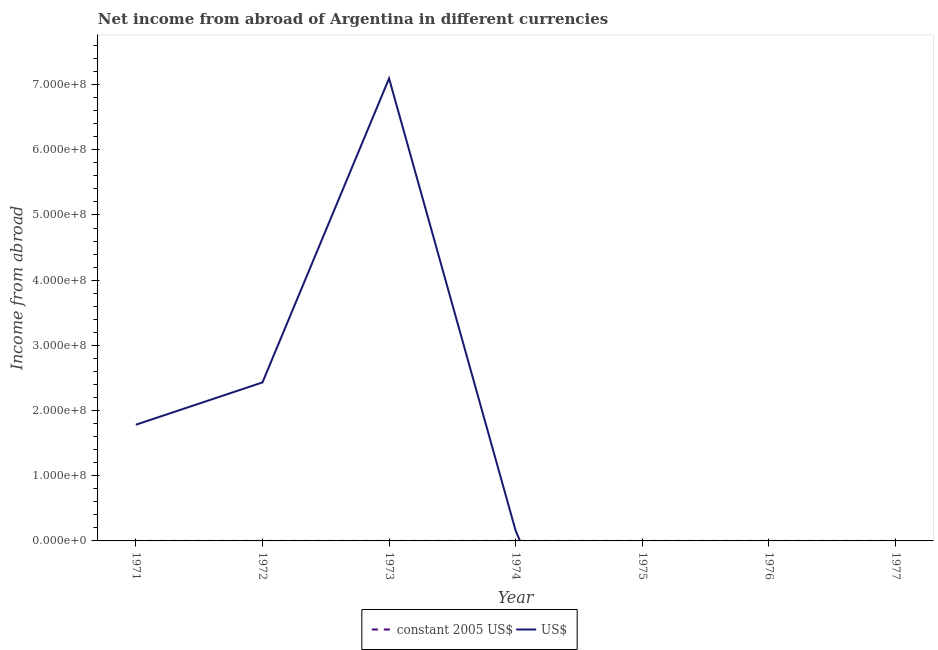Across all years, what is the maximum income from abroad in us$?
Offer a terse response. 7.09e+08. Across all years, what is the minimum income from abroad in constant 2005 us$?
Make the answer very short. 0. In which year was the income from abroad in constant 2005 us$ maximum?
Give a very brief answer. 1975. What is the total income from abroad in us$ in the graph?
Provide a succinct answer. 1.15e+09. What is the difference between the income from abroad in us$ in 1972 and that in 1973?
Offer a terse response. -4.66e+08. What is the difference between the income from abroad in constant 2005 us$ in 1977 and the income from abroad in us$ in 1973?
Your response must be concise. -7.09e+08. What is the average income from abroad in constant 2005 us$ per year?
Give a very brief answer. 0.05. In the year 1973, what is the difference between the income from abroad in constant 2005 us$ and income from abroad in us$?
Your answer should be very brief. -7.09e+08. In how many years, is the income from abroad in us$ greater than 340000000 units?
Give a very brief answer. 1. What is the ratio of the income from abroad in constant 2005 us$ in 1975 to that in 1976?
Give a very brief answer. 8.47. Is the income from abroad in constant 2005 us$ in 1971 less than that in 1976?
Make the answer very short. Yes. What is the difference between the highest and the second highest income from abroad in constant 2005 us$?
Keep it short and to the point. 0.23. What is the difference between the highest and the lowest income from abroad in constant 2005 us$?
Provide a succinct answer. 0.26. Is the sum of the income from abroad in constant 2005 us$ in 1974 and 1976 greater than the maximum income from abroad in us$ across all years?
Your answer should be very brief. No. Does the income from abroad in us$ monotonically increase over the years?
Your response must be concise. No. Is the income from abroad in us$ strictly less than the income from abroad in constant 2005 us$ over the years?
Make the answer very short. No. How many lines are there?
Keep it short and to the point. 2. How many years are there in the graph?
Provide a short and direct response. 7. What is the difference between two consecutive major ticks on the Y-axis?
Your response must be concise. 1.00e+08. Are the values on the major ticks of Y-axis written in scientific E-notation?
Your response must be concise. Yes. Does the graph contain any zero values?
Your answer should be compact. Yes. Where does the legend appear in the graph?
Offer a terse response. Bottom center. What is the title of the graph?
Provide a short and direct response. Net income from abroad of Argentina in different currencies. What is the label or title of the X-axis?
Offer a terse response. Year. What is the label or title of the Y-axis?
Offer a terse response. Income from abroad. What is the Income from abroad of constant 2005 US$ in 1971?
Ensure brevity in your answer.  0.02. What is the Income from abroad in US$ in 1971?
Make the answer very short. 1.78e+08. What is the Income from abroad in US$ in 1972?
Ensure brevity in your answer.  2.43e+08. What is the Income from abroad in constant 2005 US$ in 1973?
Your response must be concise. 0.02. What is the Income from abroad in US$ in 1973?
Keep it short and to the point. 7.09e+08. What is the Income from abroad in constant 2005 US$ in 1974?
Keep it short and to the point. 0.02. What is the Income from abroad of US$ in 1974?
Your answer should be compact. 1.55e+07. What is the Income from abroad in constant 2005 US$ in 1975?
Keep it short and to the point. 0.26. What is the Income from abroad in US$ in 1975?
Your response must be concise. 0. What is the Income from abroad in constant 2005 US$ in 1976?
Make the answer very short. 0.03. What is the Income from abroad in US$ in 1977?
Keep it short and to the point. 0. Across all years, what is the maximum Income from abroad of constant 2005 US$?
Make the answer very short. 0.26. Across all years, what is the maximum Income from abroad of US$?
Your answer should be very brief. 7.09e+08. Across all years, what is the minimum Income from abroad in US$?
Keep it short and to the point. 0. What is the total Income from abroad in constant 2005 US$ in the graph?
Your answer should be compact. 0.35. What is the total Income from abroad of US$ in the graph?
Your response must be concise. 1.15e+09. What is the difference between the Income from abroad in US$ in 1971 and that in 1972?
Your answer should be compact. -6.49e+07. What is the difference between the Income from abroad of constant 2005 US$ in 1971 and that in 1973?
Your answer should be very brief. 0. What is the difference between the Income from abroad of US$ in 1971 and that in 1973?
Offer a terse response. -5.31e+08. What is the difference between the Income from abroad of constant 2005 US$ in 1971 and that in 1974?
Give a very brief answer. -0. What is the difference between the Income from abroad in US$ in 1971 and that in 1974?
Your response must be concise. 1.63e+08. What is the difference between the Income from abroad of constant 2005 US$ in 1971 and that in 1975?
Offer a terse response. -0.25. What is the difference between the Income from abroad in constant 2005 US$ in 1971 and that in 1976?
Ensure brevity in your answer.  -0.01. What is the difference between the Income from abroad of US$ in 1972 and that in 1973?
Provide a succinct answer. -4.66e+08. What is the difference between the Income from abroad of US$ in 1972 and that in 1974?
Your answer should be very brief. 2.28e+08. What is the difference between the Income from abroad in constant 2005 US$ in 1973 and that in 1974?
Make the answer very short. -0.01. What is the difference between the Income from abroad in US$ in 1973 and that in 1974?
Make the answer very short. 6.94e+08. What is the difference between the Income from abroad of constant 2005 US$ in 1973 and that in 1975?
Make the answer very short. -0.25. What is the difference between the Income from abroad in constant 2005 US$ in 1973 and that in 1976?
Your answer should be very brief. -0.01. What is the difference between the Income from abroad in constant 2005 US$ in 1974 and that in 1975?
Your answer should be compact. -0.24. What is the difference between the Income from abroad of constant 2005 US$ in 1974 and that in 1976?
Ensure brevity in your answer.  -0.01. What is the difference between the Income from abroad of constant 2005 US$ in 1975 and that in 1976?
Ensure brevity in your answer.  0.23. What is the difference between the Income from abroad of constant 2005 US$ in 1971 and the Income from abroad of US$ in 1972?
Offer a terse response. -2.43e+08. What is the difference between the Income from abroad of constant 2005 US$ in 1971 and the Income from abroad of US$ in 1973?
Provide a succinct answer. -7.09e+08. What is the difference between the Income from abroad in constant 2005 US$ in 1971 and the Income from abroad in US$ in 1974?
Give a very brief answer. -1.55e+07. What is the difference between the Income from abroad in constant 2005 US$ in 1973 and the Income from abroad in US$ in 1974?
Make the answer very short. -1.55e+07. What is the average Income from abroad of constant 2005 US$ per year?
Your response must be concise. 0.05. What is the average Income from abroad of US$ per year?
Your response must be concise. 1.64e+08. In the year 1971, what is the difference between the Income from abroad of constant 2005 US$ and Income from abroad of US$?
Your response must be concise. -1.78e+08. In the year 1973, what is the difference between the Income from abroad of constant 2005 US$ and Income from abroad of US$?
Provide a succinct answer. -7.09e+08. In the year 1974, what is the difference between the Income from abroad in constant 2005 US$ and Income from abroad in US$?
Provide a succinct answer. -1.55e+07. What is the ratio of the Income from abroad in US$ in 1971 to that in 1972?
Offer a very short reply. 0.73. What is the ratio of the Income from abroad of constant 2005 US$ in 1971 to that in 1973?
Your response must be concise. 1.06. What is the ratio of the Income from abroad in US$ in 1971 to that in 1973?
Offer a very short reply. 0.25. What is the ratio of the Income from abroad of constant 2005 US$ in 1971 to that in 1974?
Ensure brevity in your answer.  0.78. What is the ratio of the Income from abroad of US$ in 1971 to that in 1974?
Offer a very short reply. 11.5. What is the ratio of the Income from abroad of constant 2005 US$ in 1971 to that in 1975?
Give a very brief answer. 0.07. What is the ratio of the Income from abroad in constant 2005 US$ in 1971 to that in 1976?
Ensure brevity in your answer.  0.55. What is the ratio of the Income from abroad of US$ in 1972 to that in 1973?
Make the answer very short. 0.34. What is the ratio of the Income from abroad of US$ in 1972 to that in 1974?
Your response must be concise. 15.68. What is the ratio of the Income from abroad in constant 2005 US$ in 1973 to that in 1974?
Offer a very short reply. 0.73. What is the ratio of the Income from abroad in US$ in 1973 to that in 1974?
Provide a short and direct response. 45.76. What is the ratio of the Income from abroad of constant 2005 US$ in 1973 to that in 1975?
Provide a short and direct response. 0.06. What is the ratio of the Income from abroad of constant 2005 US$ in 1973 to that in 1976?
Your answer should be very brief. 0.52. What is the ratio of the Income from abroad of constant 2005 US$ in 1974 to that in 1975?
Ensure brevity in your answer.  0.08. What is the ratio of the Income from abroad of constant 2005 US$ in 1974 to that in 1976?
Make the answer very short. 0.71. What is the ratio of the Income from abroad of constant 2005 US$ in 1975 to that in 1976?
Provide a short and direct response. 8.47. What is the difference between the highest and the second highest Income from abroad in constant 2005 US$?
Your answer should be very brief. 0.23. What is the difference between the highest and the second highest Income from abroad in US$?
Your answer should be compact. 4.66e+08. What is the difference between the highest and the lowest Income from abroad of constant 2005 US$?
Your answer should be very brief. 0.26. What is the difference between the highest and the lowest Income from abroad of US$?
Make the answer very short. 7.09e+08. 